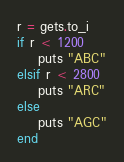<code> <loc_0><loc_0><loc_500><loc_500><_Ruby_>r = gets.to_i
if r < 1200
    puts "ABC"
elsif r < 2800
    puts "ARC"
else
    puts "AGC"
end 
</code> 